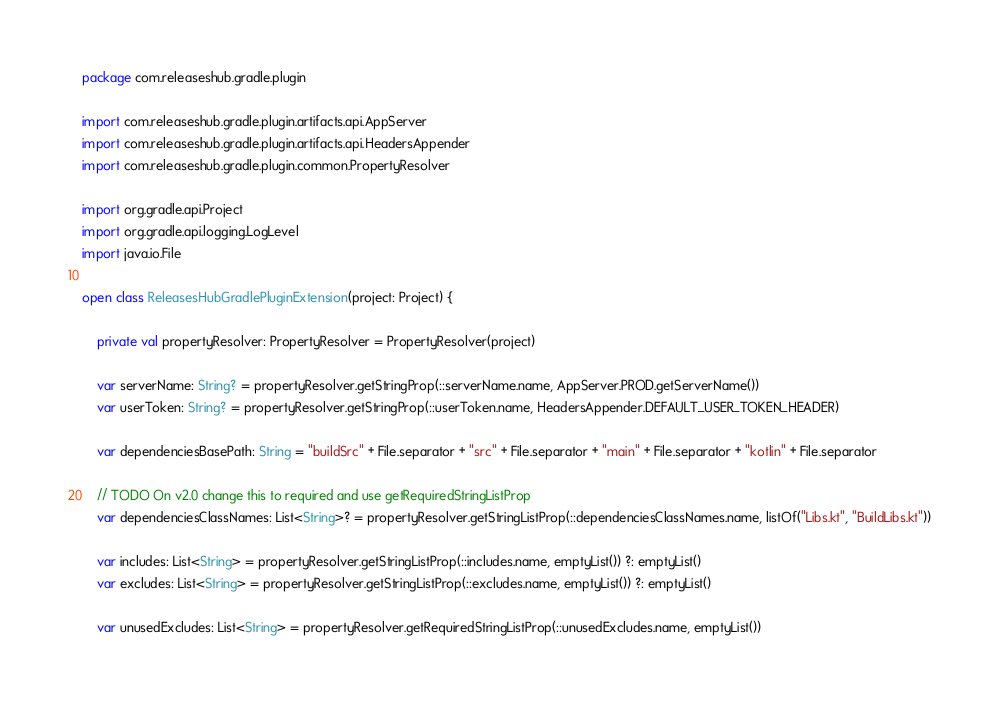<code> <loc_0><loc_0><loc_500><loc_500><_Kotlin_>package com.releaseshub.gradle.plugin

import com.releaseshub.gradle.plugin.artifacts.api.AppServer
import com.releaseshub.gradle.plugin.artifacts.api.HeadersAppender
import com.releaseshub.gradle.plugin.common.PropertyResolver

import org.gradle.api.Project
import org.gradle.api.logging.LogLevel
import java.io.File

open class ReleasesHubGradlePluginExtension(project: Project) {

    private val propertyResolver: PropertyResolver = PropertyResolver(project)

    var serverName: String? = propertyResolver.getStringProp(::serverName.name, AppServer.PROD.getServerName())
    var userToken: String? = propertyResolver.getStringProp(::userToken.name, HeadersAppender.DEFAULT_USER_TOKEN_HEADER)

    var dependenciesBasePath: String = "buildSrc" + File.separator + "src" + File.separator + "main" + File.separator + "kotlin" + File.separator

    // TODO On v2.0 change this to required and use getRequiredStringListProp
    var dependenciesClassNames: List<String>? = propertyResolver.getStringListProp(::dependenciesClassNames.name, listOf("Libs.kt", "BuildLibs.kt"))

    var includes: List<String> = propertyResolver.getStringListProp(::includes.name, emptyList()) ?: emptyList()
    var excludes: List<String> = propertyResolver.getStringListProp(::excludes.name, emptyList()) ?: emptyList()

    var unusedExcludes: List<String> = propertyResolver.getRequiredStringListProp(::unusedExcludes.name, emptyList())</code> 